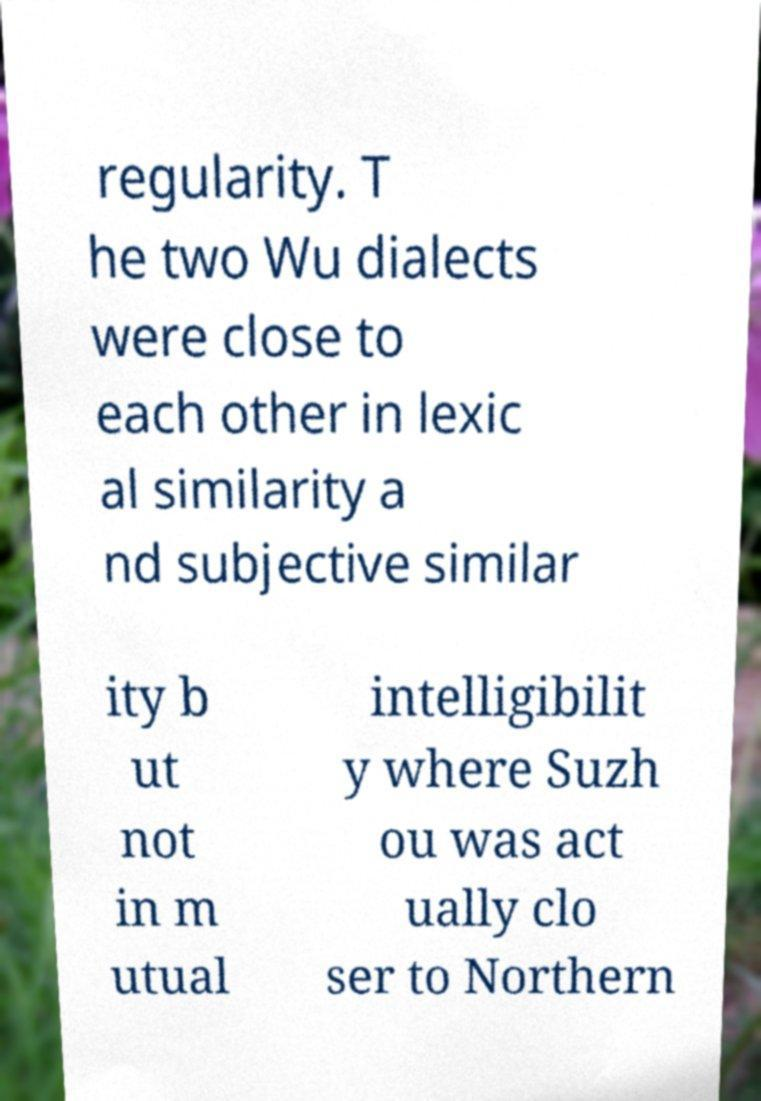I need the written content from this picture converted into text. Can you do that? regularity. T he two Wu dialects were close to each other in lexic al similarity a nd subjective similar ity b ut not in m utual intelligibilit y where Suzh ou was act ually clo ser to Northern 